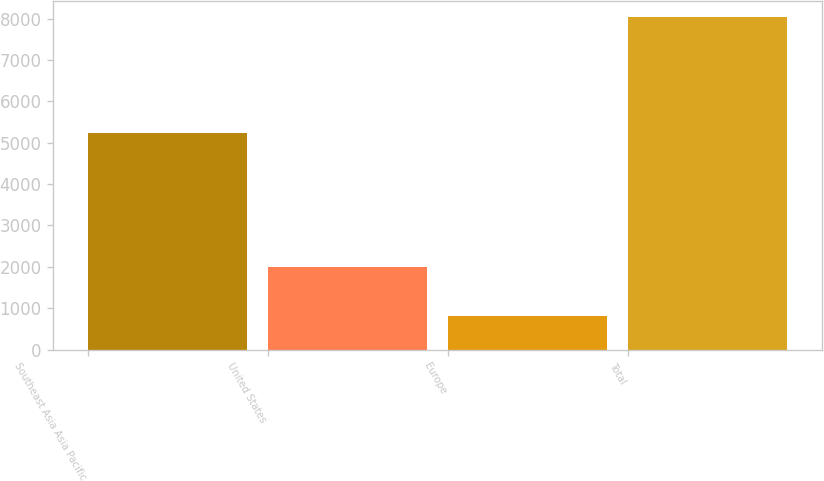<chart> <loc_0><loc_0><loc_500><loc_500><bar_chart><fcel>Southeast Asia Asia Pacific<fcel>United States<fcel>Europe<fcel>Total<nl><fcel>5225<fcel>1995<fcel>817<fcel>8037<nl></chart> 